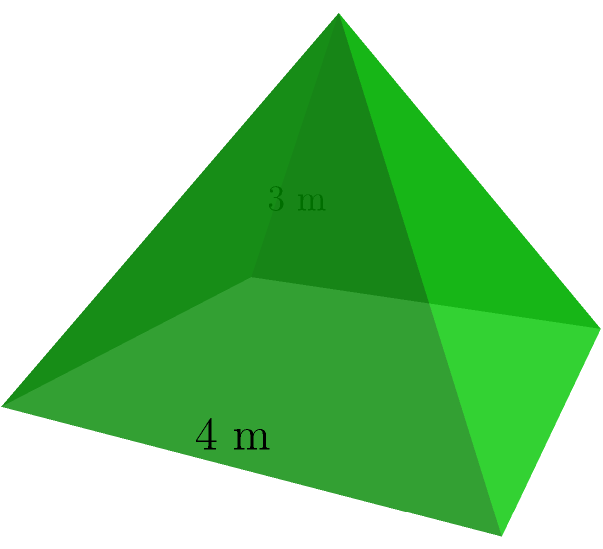You're designing a pyramid-shaped display stand for your product showcase at an upcoming trade show. The stand has a square base with sides measuring 4 meters and a height of 3 meters. Calculate the total surface area of the display stand, including the base, to determine how much material you'll need to construct it. Round your answer to the nearest whole square meter. Let's approach this step-by-step:

1) First, we need to calculate the area of the square base:
   Base area = $4 \text{ m} \times 4 \text{ m} = 16 \text{ m}^2$

2) Next, we need to find the slant height of the pyramid. We can do this using the Pythagorean theorem:
   Let $s$ be the slant height.
   $s^2 = 3^2 + 2^2$ (where 2 is half the base width)
   $s^2 = 9 + 4 = 13$
   $s = \sqrt{13} \approx 3.61 \text{ m}$

3) Now we can calculate the area of one triangular face:
   Area of one face = $\frac{1}{2} \times 4 \text{ m} \times 3.61 \text{ m} = 7.22 \text{ m}^2$

4) There are four identical triangular faces, so:
   Total area of faces = $4 \times 7.22 \text{ m}^2 = 28.88 \text{ m}^2$

5) The total surface area is the sum of the base area and the area of all faces:
   Total surface area = $16 \text{ m}^2 + 28.88 \text{ m}^2 = 44.88 \text{ m}^2$

6) Rounding to the nearest whole square meter:
   Total surface area ≈ 45 m²
Answer: 45 m² 